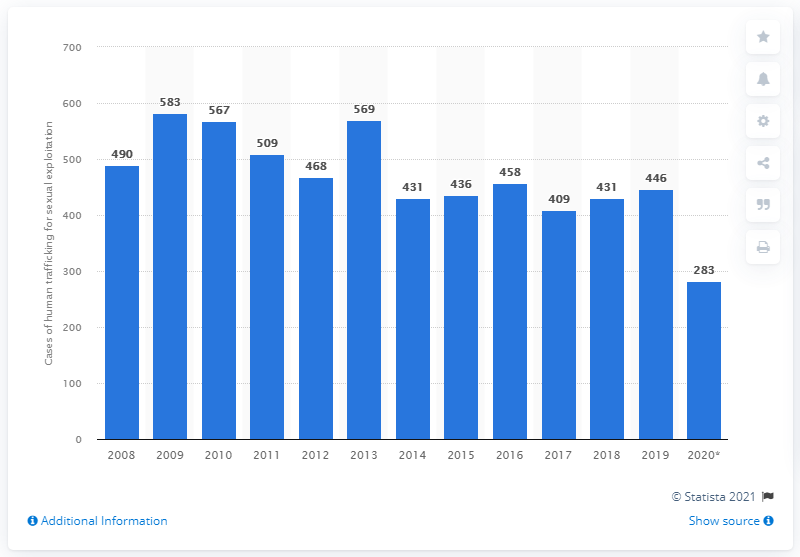How many sexual trafficking cases were registered in 2020? According to the bar chart provided, there were 283 cases of human trafficking for sexual exploitation registered in 2020. The graph indicates a decreasing trend from the previous years, marking the lowest number of cases in the given time range from 2008 to 2020. 